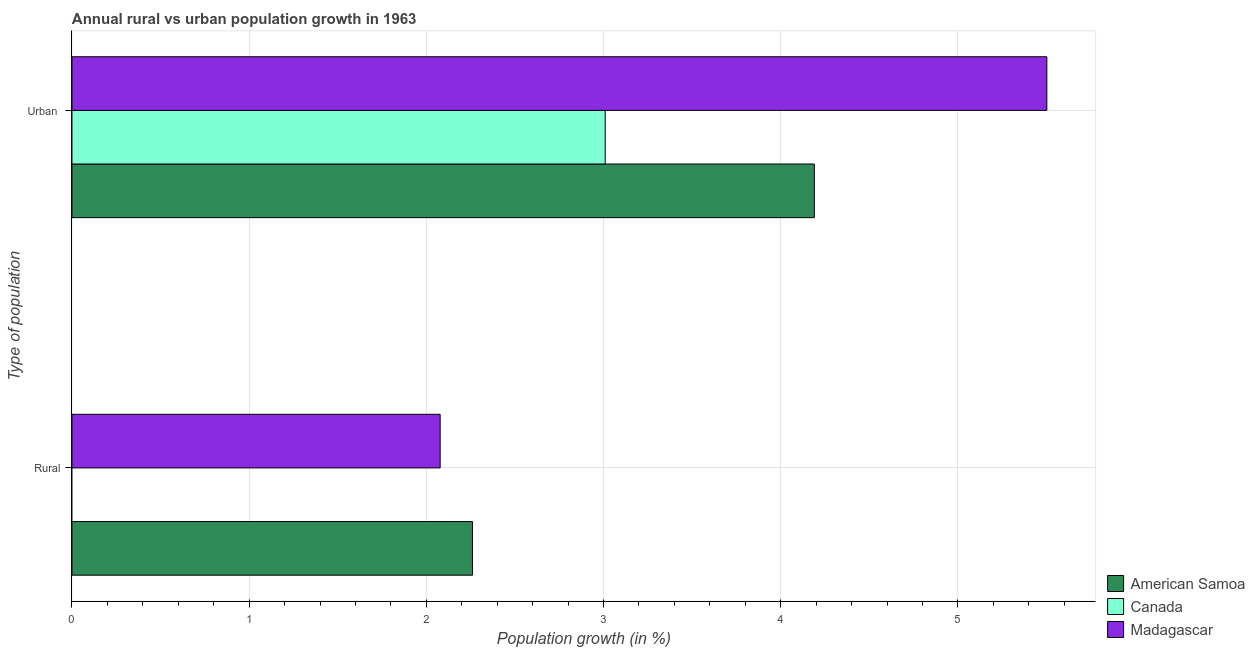How many bars are there on the 1st tick from the top?
Your answer should be very brief. 3. What is the label of the 2nd group of bars from the top?
Ensure brevity in your answer.  Rural. Across all countries, what is the maximum rural population growth?
Provide a short and direct response. 2.26. Across all countries, what is the minimum urban population growth?
Keep it short and to the point. 3.01. In which country was the rural population growth maximum?
Give a very brief answer. American Samoa. What is the total urban population growth in the graph?
Ensure brevity in your answer.  12.7. What is the difference between the rural population growth in Madagascar and that in American Samoa?
Make the answer very short. -0.18. What is the difference between the urban population growth in Canada and the rural population growth in Madagascar?
Your answer should be compact. 0.93. What is the average urban population growth per country?
Ensure brevity in your answer.  4.23. What is the difference between the rural population growth and urban population growth in Madagascar?
Your response must be concise. -3.42. What is the ratio of the rural population growth in American Samoa to that in Madagascar?
Offer a terse response. 1.09. In how many countries, is the rural population growth greater than the average rural population growth taken over all countries?
Your answer should be very brief. 2. How many bars are there?
Make the answer very short. 5. Are all the bars in the graph horizontal?
Provide a short and direct response. Yes. How many countries are there in the graph?
Provide a succinct answer. 3. Are the values on the major ticks of X-axis written in scientific E-notation?
Make the answer very short. No. Does the graph contain grids?
Offer a very short reply. Yes. How many legend labels are there?
Your answer should be compact. 3. How are the legend labels stacked?
Keep it short and to the point. Vertical. What is the title of the graph?
Your answer should be compact. Annual rural vs urban population growth in 1963. Does "Bosnia and Herzegovina" appear as one of the legend labels in the graph?
Make the answer very short. No. What is the label or title of the X-axis?
Offer a very short reply. Population growth (in %). What is the label or title of the Y-axis?
Give a very brief answer. Type of population. What is the Population growth (in %) of American Samoa in Rural?
Your response must be concise. 2.26. What is the Population growth (in %) in Madagascar in Rural?
Your answer should be compact. 2.08. What is the Population growth (in %) of American Samoa in Urban ?
Offer a terse response. 4.19. What is the Population growth (in %) of Canada in Urban ?
Give a very brief answer. 3.01. What is the Population growth (in %) of Madagascar in Urban ?
Make the answer very short. 5.5. Across all Type of population, what is the maximum Population growth (in %) of American Samoa?
Your response must be concise. 4.19. Across all Type of population, what is the maximum Population growth (in %) in Canada?
Offer a terse response. 3.01. Across all Type of population, what is the maximum Population growth (in %) in Madagascar?
Your response must be concise. 5.5. Across all Type of population, what is the minimum Population growth (in %) of American Samoa?
Ensure brevity in your answer.  2.26. Across all Type of population, what is the minimum Population growth (in %) in Madagascar?
Make the answer very short. 2.08. What is the total Population growth (in %) in American Samoa in the graph?
Your answer should be very brief. 6.45. What is the total Population growth (in %) of Canada in the graph?
Provide a succinct answer. 3.01. What is the total Population growth (in %) in Madagascar in the graph?
Make the answer very short. 7.58. What is the difference between the Population growth (in %) of American Samoa in Rural and that in Urban ?
Provide a succinct answer. -1.93. What is the difference between the Population growth (in %) of Madagascar in Rural and that in Urban ?
Give a very brief answer. -3.42. What is the difference between the Population growth (in %) of American Samoa in Rural and the Population growth (in %) of Canada in Urban ?
Provide a succinct answer. -0.75. What is the difference between the Population growth (in %) of American Samoa in Rural and the Population growth (in %) of Madagascar in Urban ?
Offer a very short reply. -3.24. What is the average Population growth (in %) of American Samoa per Type of population?
Offer a terse response. 3.23. What is the average Population growth (in %) of Canada per Type of population?
Offer a terse response. 1.5. What is the average Population growth (in %) of Madagascar per Type of population?
Offer a terse response. 3.79. What is the difference between the Population growth (in %) in American Samoa and Population growth (in %) in Madagascar in Rural?
Provide a short and direct response. 0.18. What is the difference between the Population growth (in %) of American Samoa and Population growth (in %) of Canada in Urban ?
Give a very brief answer. 1.18. What is the difference between the Population growth (in %) of American Samoa and Population growth (in %) of Madagascar in Urban ?
Your answer should be compact. -1.31. What is the difference between the Population growth (in %) in Canada and Population growth (in %) in Madagascar in Urban ?
Ensure brevity in your answer.  -2.49. What is the ratio of the Population growth (in %) of American Samoa in Rural to that in Urban ?
Give a very brief answer. 0.54. What is the ratio of the Population growth (in %) in Madagascar in Rural to that in Urban ?
Offer a very short reply. 0.38. What is the difference between the highest and the second highest Population growth (in %) in American Samoa?
Your response must be concise. 1.93. What is the difference between the highest and the second highest Population growth (in %) in Madagascar?
Offer a terse response. 3.42. What is the difference between the highest and the lowest Population growth (in %) of American Samoa?
Offer a terse response. 1.93. What is the difference between the highest and the lowest Population growth (in %) in Canada?
Offer a very short reply. 3.01. What is the difference between the highest and the lowest Population growth (in %) of Madagascar?
Provide a succinct answer. 3.42. 